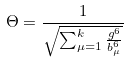Convert formula to latex. <formula><loc_0><loc_0><loc_500><loc_500>\Theta = \frac { 1 } { \sqrt { \sum _ { \mu = 1 } ^ { k } \frac { g ^ { 6 } } { b _ { \mu } ^ { 6 } } } }</formula> 